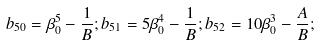Convert formula to latex. <formula><loc_0><loc_0><loc_500><loc_500>b _ { 5 0 } = \beta _ { 0 } ^ { 5 } - \frac { 1 } { B } ; b _ { 5 1 } = 5 \beta _ { 0 } ^ { 4 } - \frac { 1 } { B } ; b _ { 5 2 } = 1 0 \beta _ { 0 } ^ { 3 } - \frac { A } { B } ;</formula> 